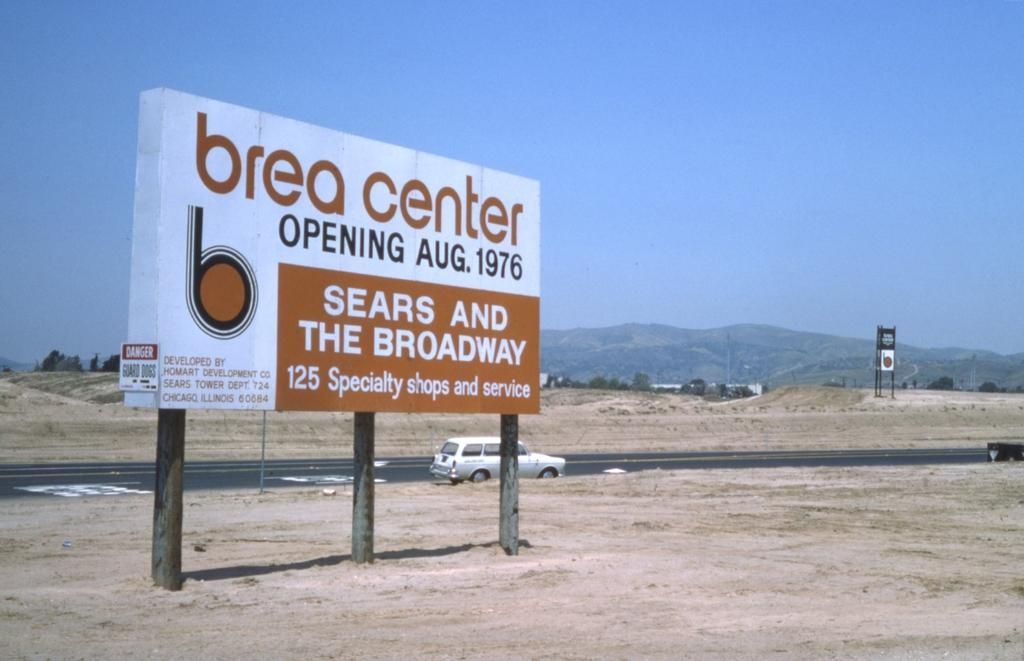<image>
Share a concise interpretation of the image provided. A large billboard in an empty field announces that the Brea Center will be opening in August 1976 